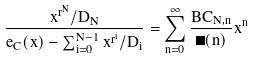<formula> <loc_0><loc_0><loc_500><loc_500>\frac { x ^ { r ^ { N } } / D _ { N } } { e _ { C } ( x ) - \sum _ { i = 0 } ^ { N - 1 } x ^ { r ^ { i } } / D _ { i } } = \sum _ { n = 0 } ^ { \infty } \frac { B C _ { N , n } } { \Pi ( n ) } x ^ { n }</formula> 